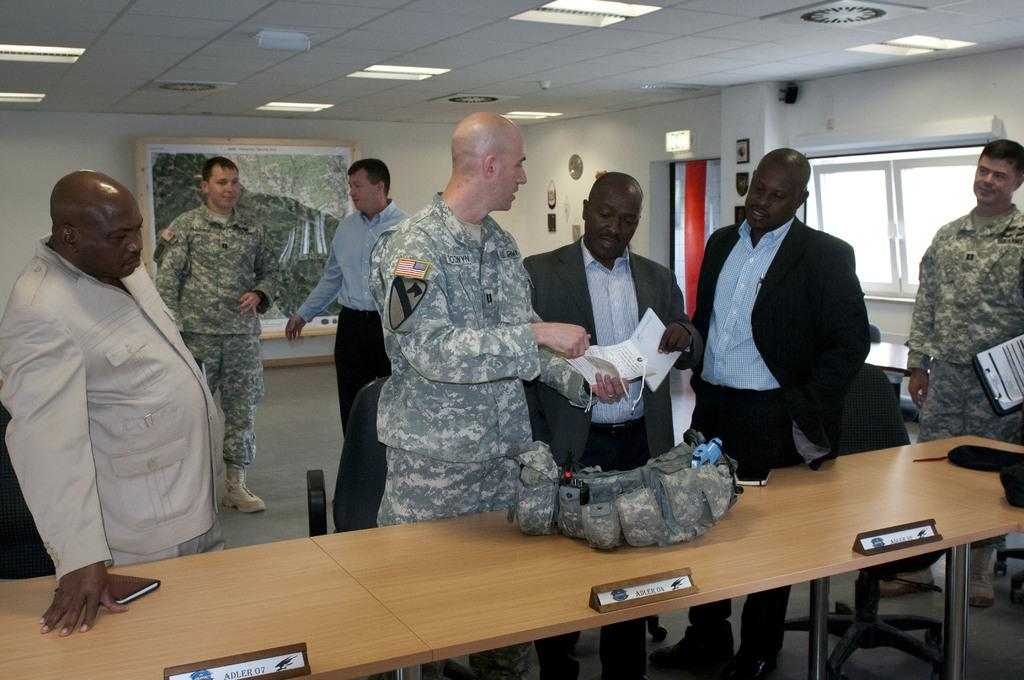What type of structure can be seen in the image? There is a wall in the image. Are there any openings in the wall? Yes, there are windows in the image. What is hanging on the wall? There is a photo frame in the image. What type of lighting is present in the image? There are lights in the image. Can you describe the people in the image? There are people in the image. What type of furniture is visible in the image? There are tables in the image. Is there any wall decoration on the table? There is a wall hanging on a table in the image. How many visitors are present in the image? There is no mention of visitors in the image; it only shows a wall, windows, a photo frame, lights, people, tables, and a wall hanging on a table. What type of can is visible in the image? There is no can present in the image. Is there a porter carrying luggage in the image? There is no porter or luggage present in the image. 